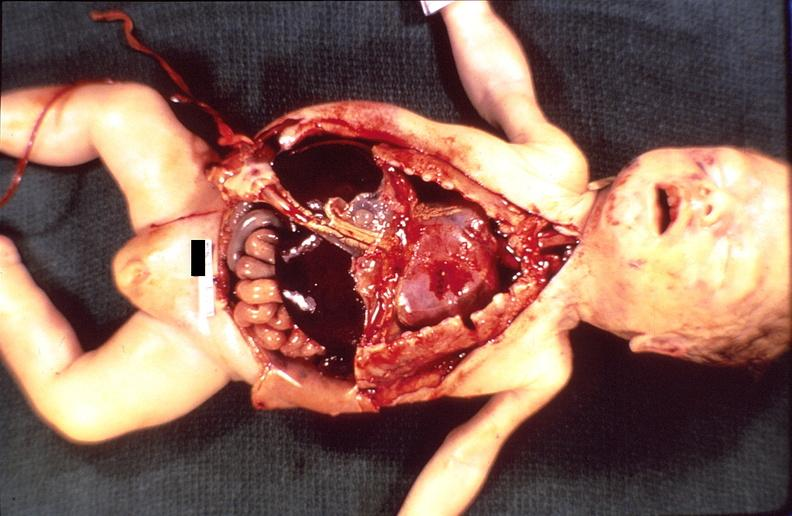does this image show hemolytic disease of newborn?
Answer the question using a single word or phrase. Yes 